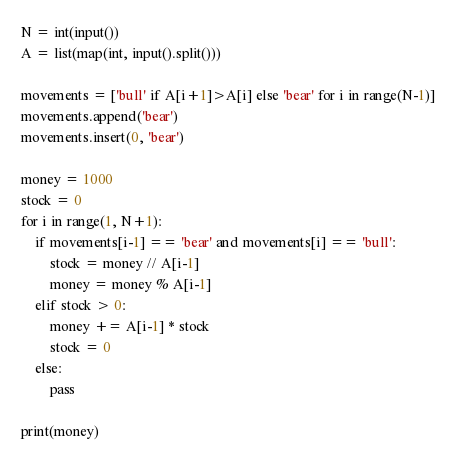Convert code to text. <code><loc_0><loc_0><loc_500><loc_500><_Python_>N = int(input())
A = list(map(int, input().split()))

movements = ['bull' if A[i+1]>A[i] else 'bear' for i in range(N-1)]
movements.append('bear')
movements.insert(0, 'bear')

money = 1000
stock = 0
for i in range(1, N+1):
    if movements[i-1] == 'bear' and movements[i] == 'bull':
        stock = money // A[i-1]
        money = money % A[i-1]
    elif stock > 0:
        money += A[i-1] * stock
        stock = 0
    else:
        pass

print(money)
</code> 